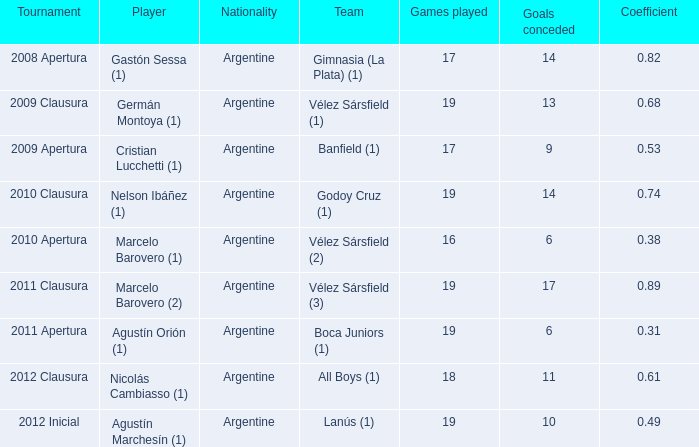Can you provide the coefficient associated with agustín marchesín (1)? 0.49. 